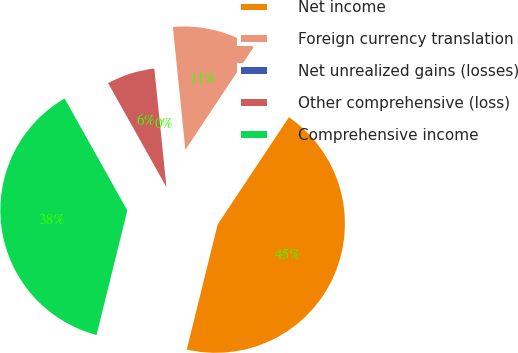Convert chart to OTSL. <chart><loc_0><loc_0><loc_500><loc_500><pie_chart><fcel>Net income<fcel>Foreign currency translation<fcel>Net unrealized gains (losses)<fcel>Other comprehensive (loss)<fcel>Comprehensive income<nl><fcel>44.52%<fcel>10.95%<fcel>0.01%<fcel>6.5%<fcel>38.02%<nl></chart> 